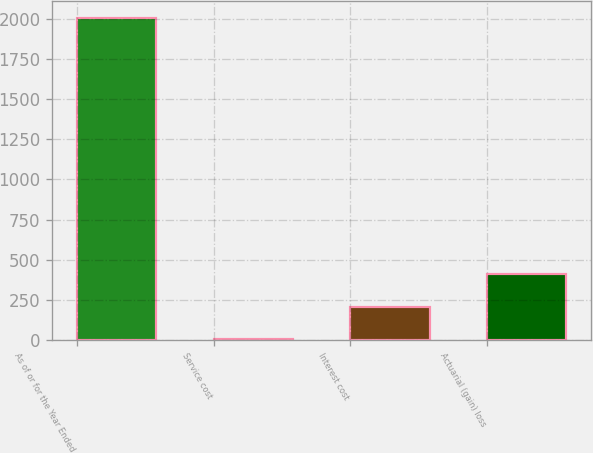Convert chart. <chart><loc_0><loc_0><loc_500><loc_500><bar_chart><fcel>As of or for the Year Ended<fcel>Service cost<fcel>Interest cost<fcel>Actuarial (gain) loss<nl><fcel>2008<fcel>8<fcel>208<fcel>408<nl></chart> 